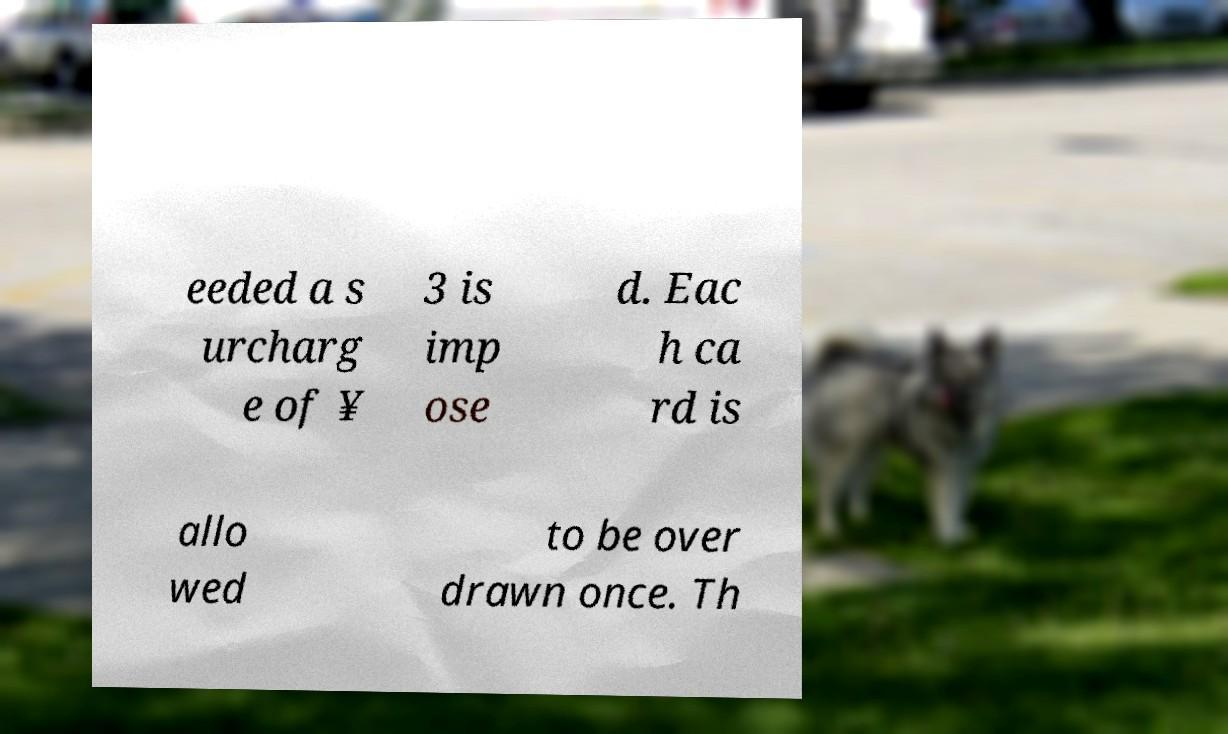Can you accurately transcribe the text from the provided image for me? eeded a s urcharg e of ¥ 3 is imp ose d. Eac h ca rd is allo wed to be over drawn once. Th 